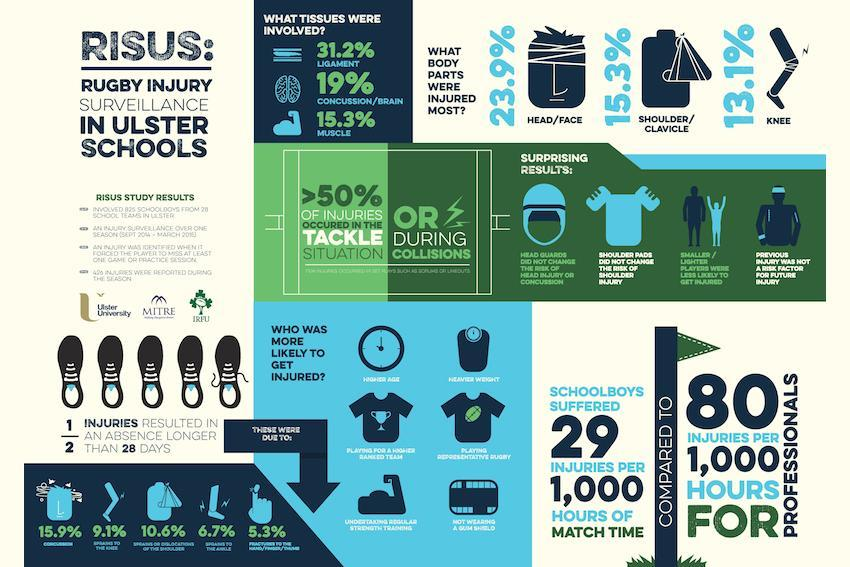Which tissue had least chances of being injured, muscle, brain, or ligament?
Answer the question with a short phrase. muscle What is the difference in the number of injuries suffered by professionals in comparison to school boys? 51 Which body part had the highest percentage of injuries, shoulder, knee, or head? head 